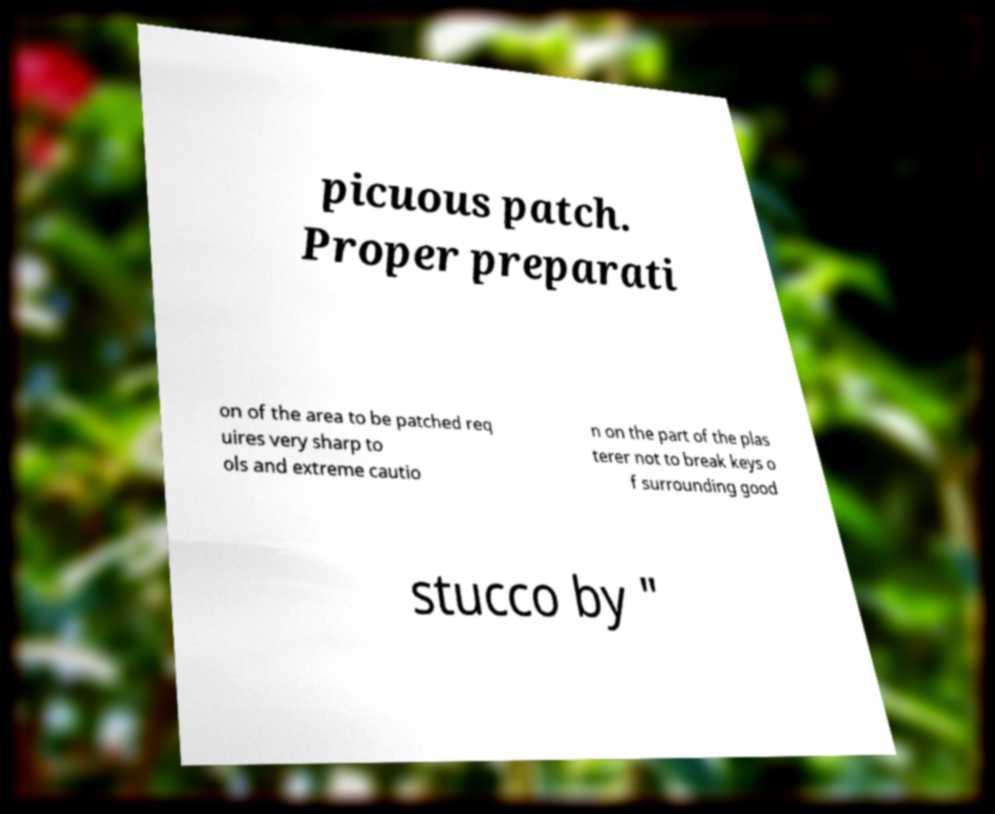I need the written content from this picture converted into text. Can you do that? picuous patch. Proper preparati on of the area to be patched req uires very sharp to ols and extreme cautio n on the part of the plas terer not to break keys o f surrounding good stucco by " 